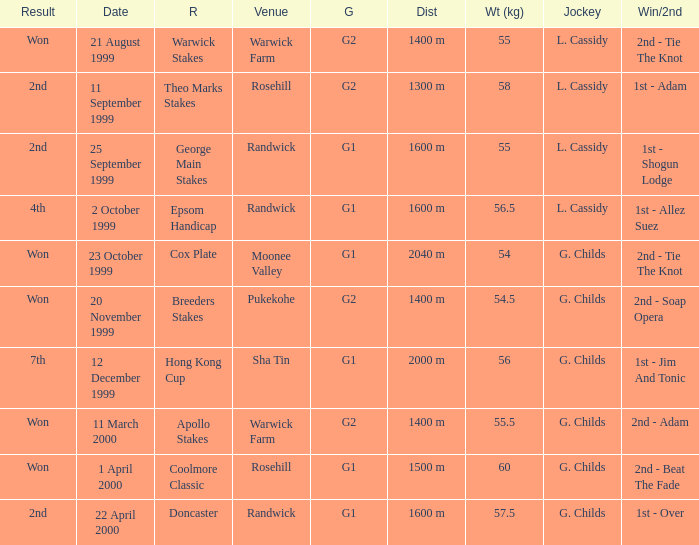List the weight for 56.5 kilograms. Epsom Handicap. 